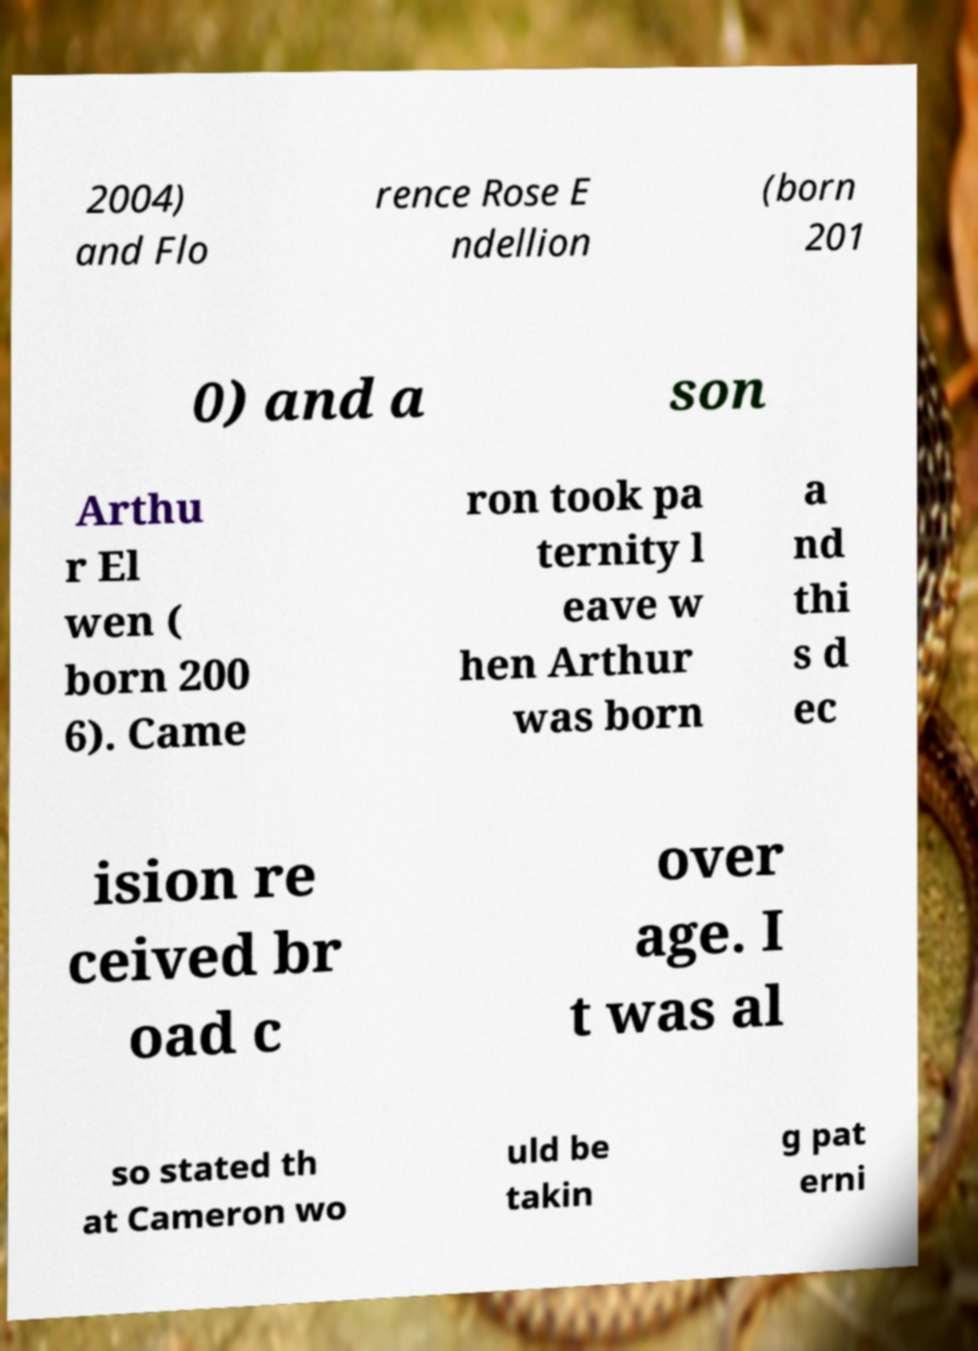Please identify and transcribe the text found in this image. 2004) and Flo rence Rose E ndellion (born 201 0) and a son Arthu r El wen ( born 200 6). Came ron took pa ternity l eave w hen Arthur was born a nd thi s d ec ision re ceived br oad c over age. I t was al so stated th at Cameron wo uld be takin g pat erni 